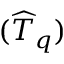Convert formula to latex. <formula><loc_0><loc_0><loc_500><loc_500>( \widehat { T } _ { q } )</formula> 